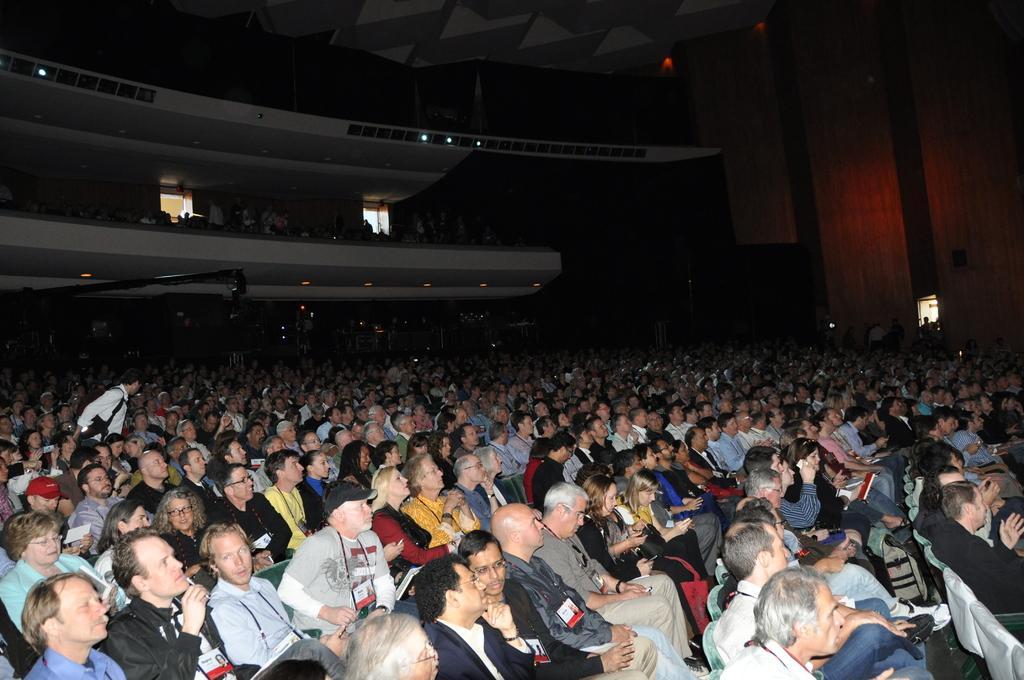Could you give a brief overview of what you see in this image? It is looks like an auditorium. There are so many people are sitting on the chairs. Background there is a wall. Here we can see few people are standing. Top of the image, there is a roof. 